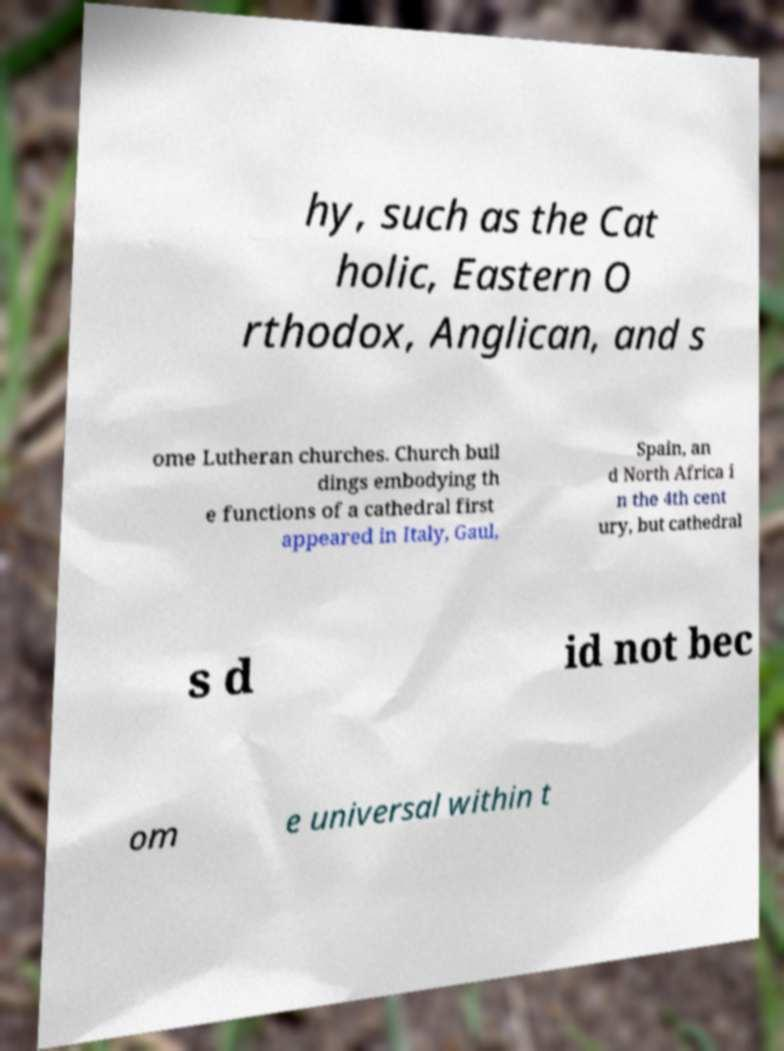Could you extract and type out the text from this image? hy, such as the Cat holic, Eastern O rthodox, Anglican, and s ome Lutheran churches. Church buil dings embodying th e functions of a cathedral first appeared in Italy, Gaul, Spain, an d North Africa i n the 4th cent ury, but cathedral s d id not bec om e universal within t 